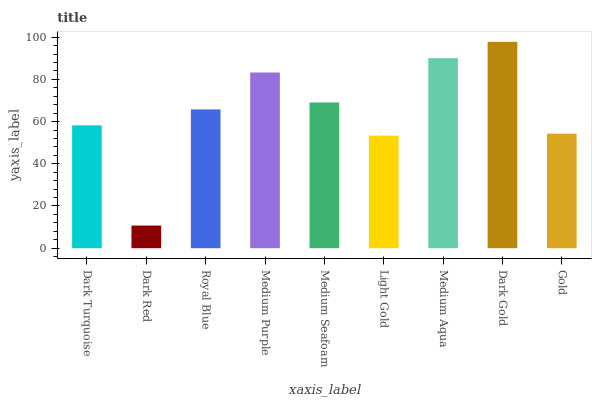Is Dark Gold the maximum?
Answer yes or no. Yes. Is Royal Blue the minimum?
Answer yes or no. No. Is Royal Blue the maximum?
Answer yes or no. No. Is Royal Blue greater than Dark Red?
Answer yes or no. Yes. Is Dark Red less than Royal Blue?
Answer yes or no. Yes. Is Dark Red greater than Royal Blue?
Answer yes or no. No. Is Royal Blue less than Dark Red?
Answer yes or no. No. Is Royal Blue the high median?
Answer yes or no. Yes. Is Royal Blue the low median?
Answer yes or no. Yes. Is Dark Gold the high median?
Answer yes or no. No. Is Dark Turquoise the low median?
Answer yes or no. No. 